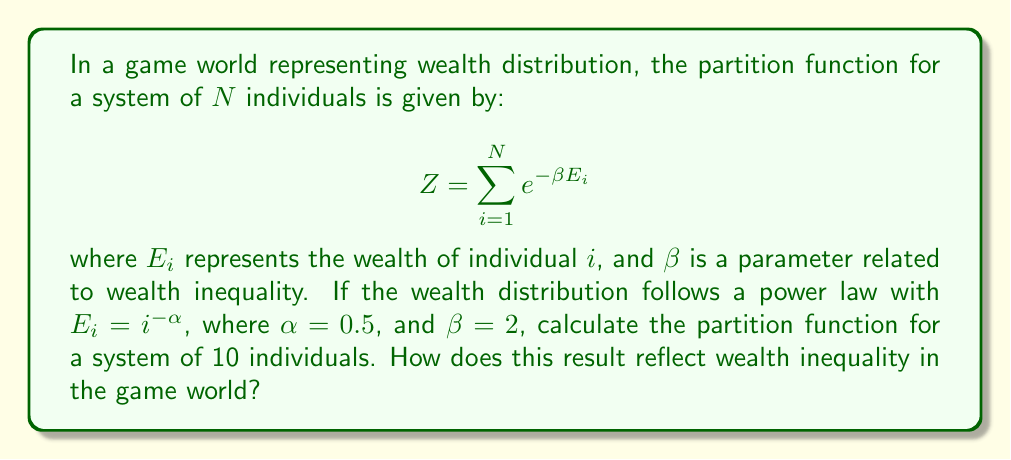Help me with this question. To solve this problem, we'll follow these steps:

1) First, let's expand the partition function for N = 10:

   $$ Z = \sum_{i=1}^{10} e^{-\beta E_i} $$

2) We're given that $E_i = i^{-\alpha}$ with $\alpha = 0.5$, and $\beta = 2$. Let's substitute these:

   $$ Z = \sum_{i=1}^{10} e^{-2 \cdot i^{-0.5}} $$

3) Now, we need to calculate this sum. Let's compute each term:

   $i = 1$: $e^{-2 \cdot 1^{-0.5}} = e^{-2} \approx 0.1353$
   $i = 2$: $e^{-2 \cdot 2^{-0.5}} = e^{-\sqrt{2}} \approx 0.2431$
   $i = 3$: $e^{-2 \cdot 3^{-0.5}} \approx 0.3169$
   $i = 4$: $e^{-2 \cdot 4^{-0.5}} \approx 0.3679$
   $i = 5$: $e^{-2 \cdot 5^{-0.5}} \approx 0.4066$
   $i = 6$: $e^{-2 \cdot 6^{-0.5}} \approx 0.4370$
   $i = 7$: $e^{-2 \cdot 7^{-0.5}} \approx 0.4617$
   $i = 8$: $e^{-2 \cdot 8^{-0.5}} \approx 0.4822$
   $i = 9$: $e^{-2 \cdot 9^{-0.5}} \approx 0.4996$
   $i = 10$: $e^{-2 \cdot 10^{-0.5}} \approx 0.5146$

4) Sum all these terms:

   $Z \approx 3.8649$

5) Interpretation: The partition function gives us information about the distribution of wealth in our game world. A larger partition function indicates a more even distribution of wealth, while a smaller one suggests greater inequality. In this case, the value of 3.8649 for 10 individuals is relatively small, indicating significant wealth inequality. The power law distribution with $\alpha = 0.5$ creates a system where a few individuals have much more wealth than others, mirroring real-world wealth disparities.
Answer: $Z \approx 3.8649$, indicating significant wealth inequality in the game world. 